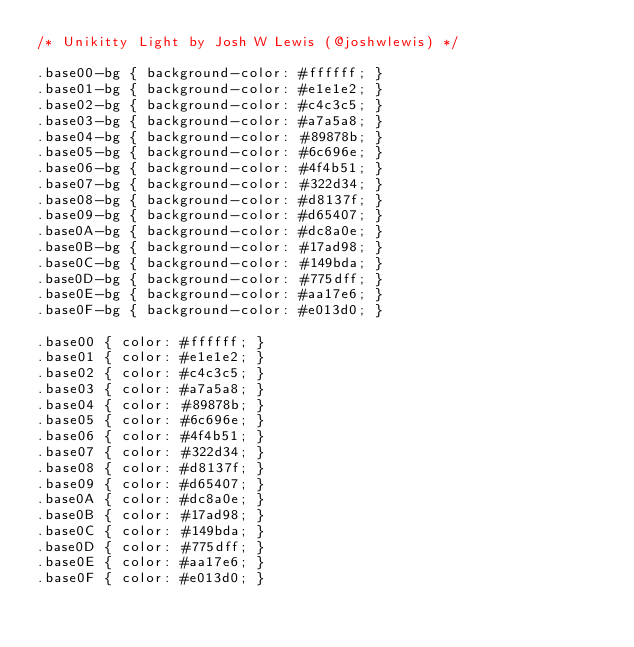<code> <loc_0><loc_0><loc_500><loc_500><_CSS_>/* Unikitty Light by Josh W Lewis (@joshwlewis) */

.base00-bg { background-color: #ffffff; }
.base01-bg { background-color: #e1e1e2; }
.base02-bg { background-color: #c4c3c5; }
.base03-bg { background-color: #a7a5a8; }
.base04-bg { background-color: #89878b; }
.base05-bg { background-color: #6c696e; }
.base06-bg { background-color: #4f4b51; }
.base07-bg { background-color: #322d34; }
.base08-bg { background-color: #d8137f; }
.base09-bg { background-color: #d65407; }
.base0A-bg { background-color: #dc8a0e; }
.base0B-bg { background-color: #17ad98; }
.base0C-bg { background-color: #149bda; }
.base0D-bg { background-color: #775dff; }
.base0E-bg { background-color: #aa17e6; }
.base0F-bg { background-color: #e013d0; }

.base00 { color: #ffffff; }
.base01 { color: #e1e1e2; }
.base02 { color: #c4c3c5; }
.base03 { color: #a7a5a8; }
.base04 { color: #89878b; }
.base05 { color: #6c696e; }
.base06 { color: #4f4b51; }
.base07 { color: #322d34; }
.base08 { color: #d8137f; }
.base09 { color: #d65407; }
.base0A { color: #dc8a0e; }
.base0B { color: #17ad98; }
.base0C { color: #149bda; }
.base0D { color: #775dff; }
.base0E { color: #aa17e6; }
.base0F { color: #e013d0; }
</code> 